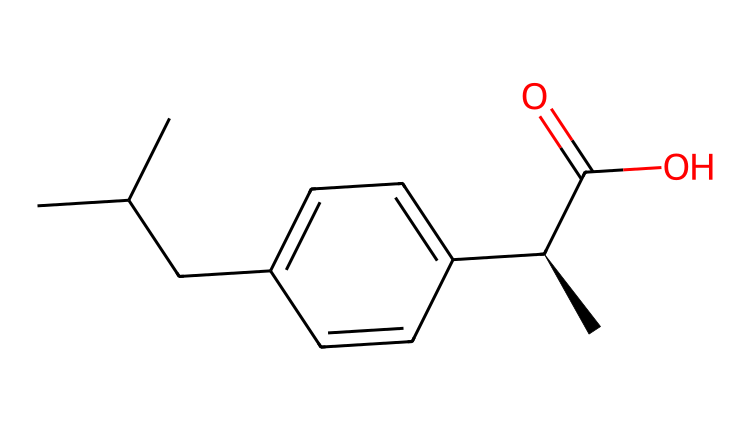What is the name of this chiral compound? The SMILES representation corresponds to ibuprofen, a widely used non-steroidal anti-inflammatory drug.
Answer: ibuprofen How many chiral centers does ibuprofen have? By analyzing the structure, there is one carbon atom connected to four different groups, indicating one chiral center.
Answer: one What is the functional group present in ibuprofen? The -C(=O)O group indicates the presence of a carboxylic acid functional group, which is key for its activity as a pain reliever.
Answer: carboxylic acid What type of isomerism does ibuprofen exhibit? As a chiral compound with one chiral center, ibuprofen exhibits optical isomerism, where it can exist in two enantiomeric forms.
Answer: optical isomerism What is the configuration at the chiral center in ibuprofen? The chiral center in the SMILES shows the stereochemical designation as [C@H], indicating it has an S configuration based on the Cahn-Ingold-Prelog priority rules.
Answer: S configuration 